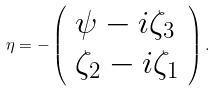<formula> <loc_0><loc_0><loc_500><loc_500>\eta = - \left ( \begin{array} { l l } \psi - i \zeta _ { 3 } \\ \zeta _ { 2 } - i \zeta _ { 1 } \end{array} \right ) .</formula> 